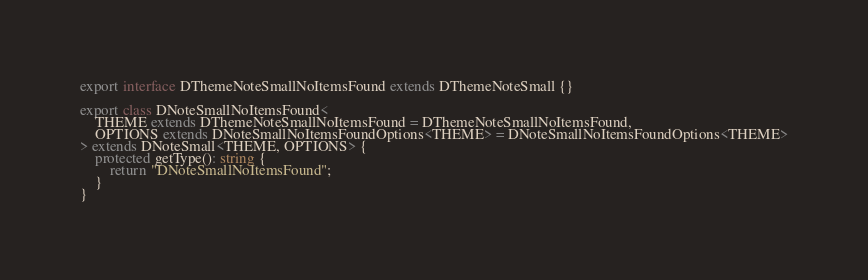Convert code to text. <code><loc_0><loc_0><loc_500><loc_500><_TypeScript_>export interface DThemeNoteSmallNoItemsFound extends DThemeNoteSmall {}

export class DNoteSmallNoItemsFound<
	THEME extends DThemeNoteSmallNoItemsFound = DThemeNoteSmallNoItemsFound,
	OPTIONS extends DNoteSmallNoItemsFoundOptions<THEME> = DNoteSmallNoItemsFoundOptions<THEME>
> extends DNoteSmall<THEME, OPTIONS> {
	protected getType(): string {
		return "DNoteSmallNoItemsFound";
	}
}
</code> 